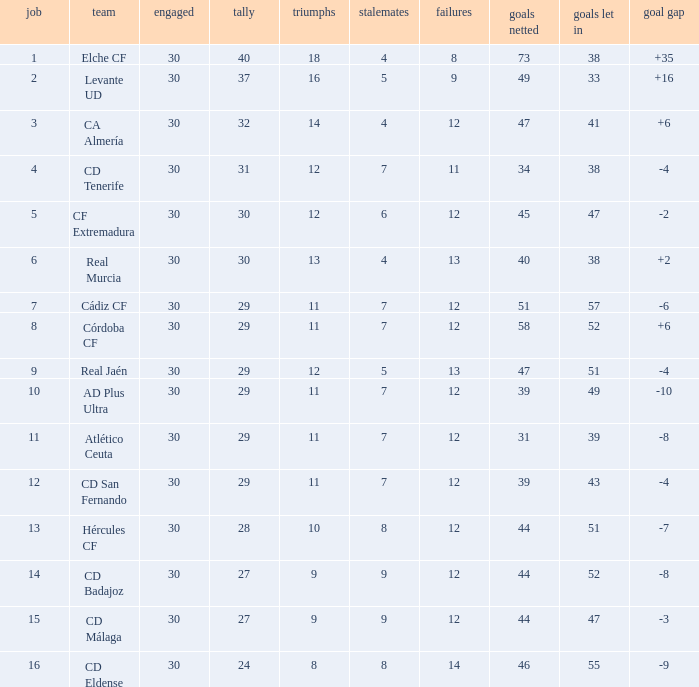What is the lowest amount of draws with less than 12 wins and less than 30 played? None. 